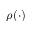<formula> <loc_0><loc_0><loc_500><loc_500>\rho ( \cdot )</formula> 